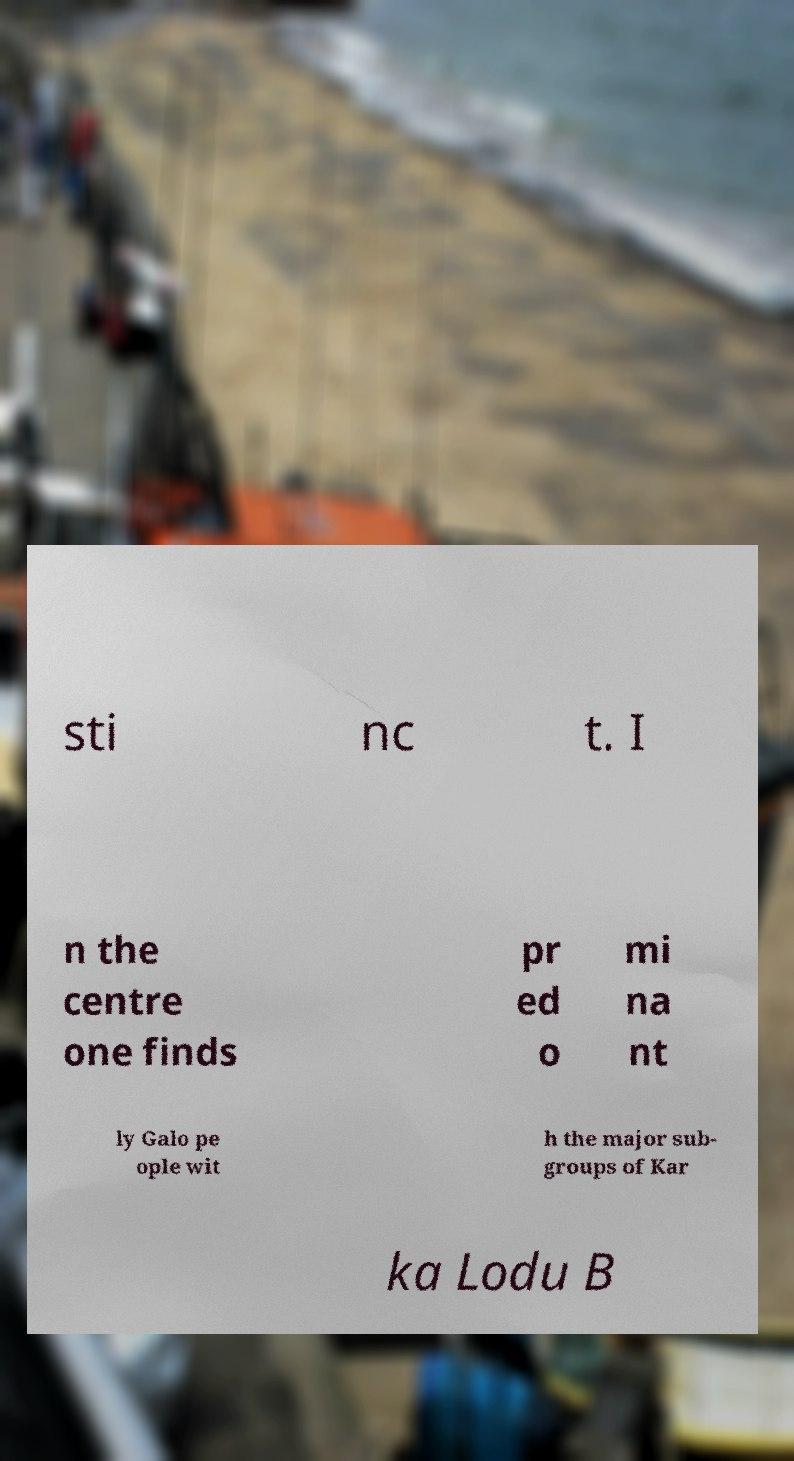Please identify and transcribe the text found in this image. sti nc t. I n the centre one finds pr ed o mi na nt ly Galo pe ople wit h the major sub- groups of Kar ka Lodu B 